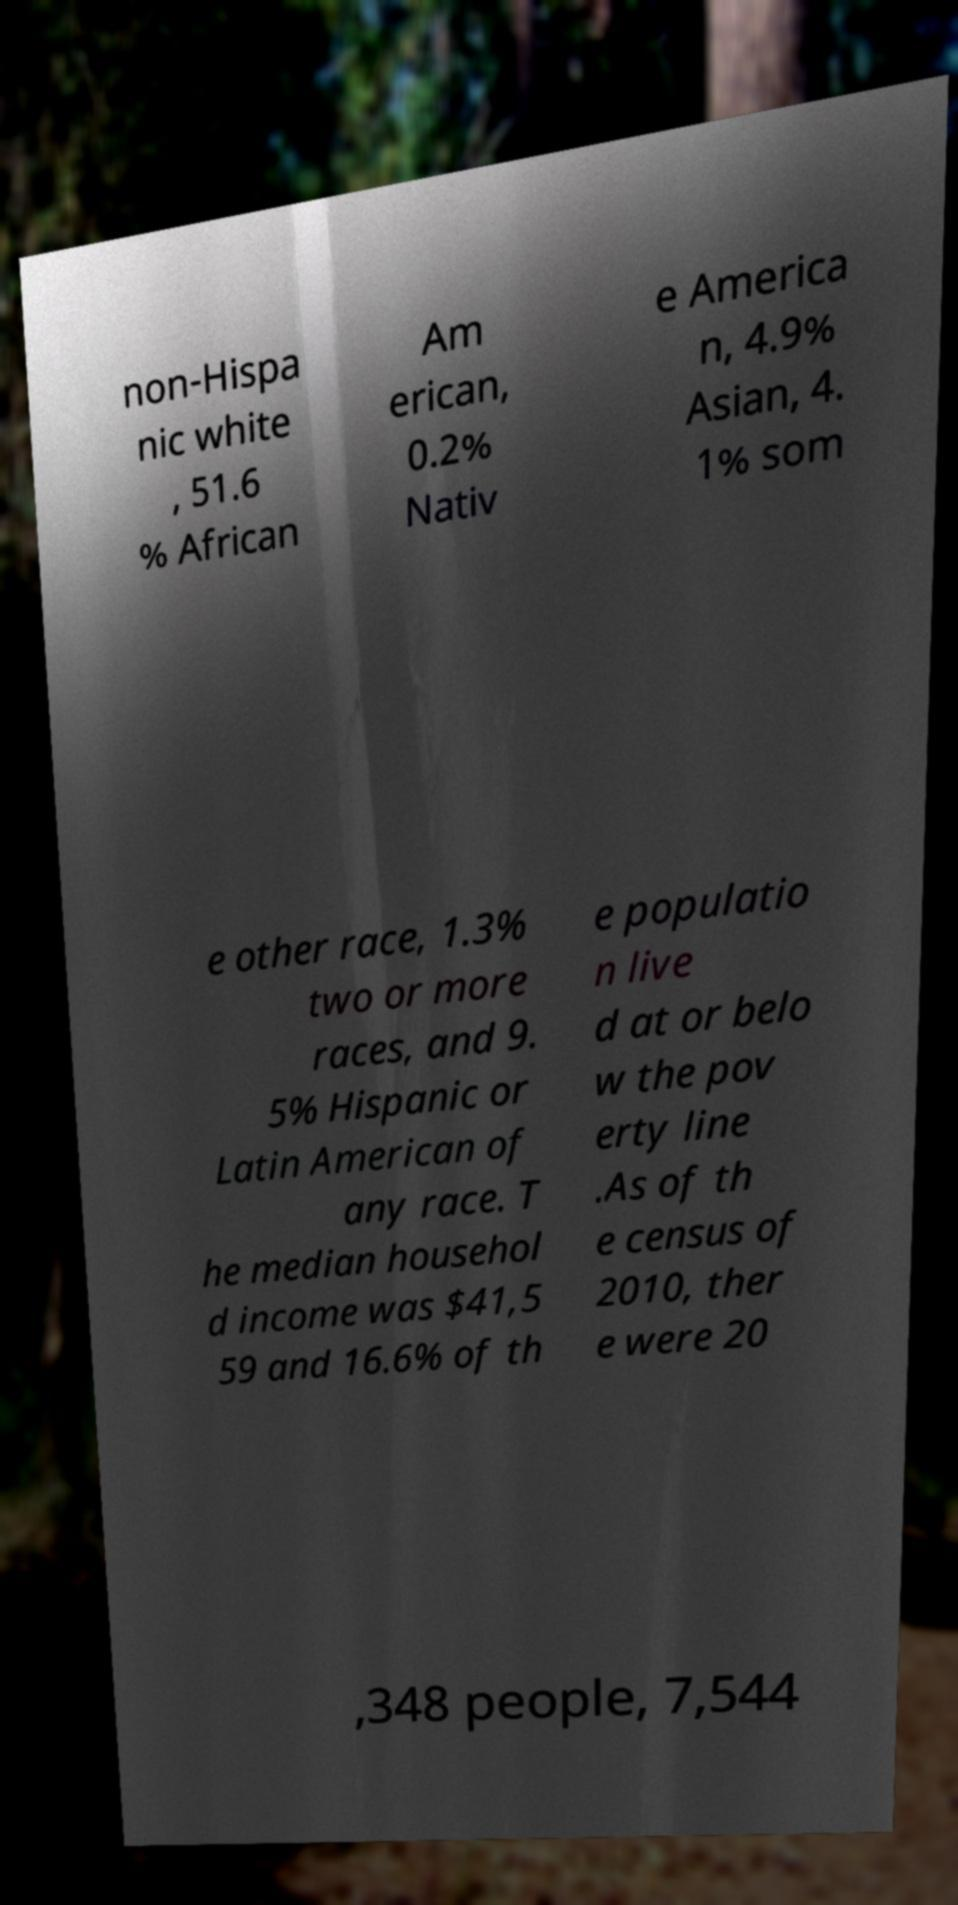Could you assist in decoding the text presented in this image and type it out clearly? non-Hispa nic white , 51.6 % African Am erican, 0.2% Nativ e America n, 4.9% Asian, 4. 1% som e other race, 1.3% two or more races, and 9. 5% Hispanic or Latin American of any race. T he median househol d income was $41,5 59 and 16.6% of th e populatio n live d at or belo w the pov erty line .As of th e census of 2010, ther e were 20 ,348 people, 7,544 